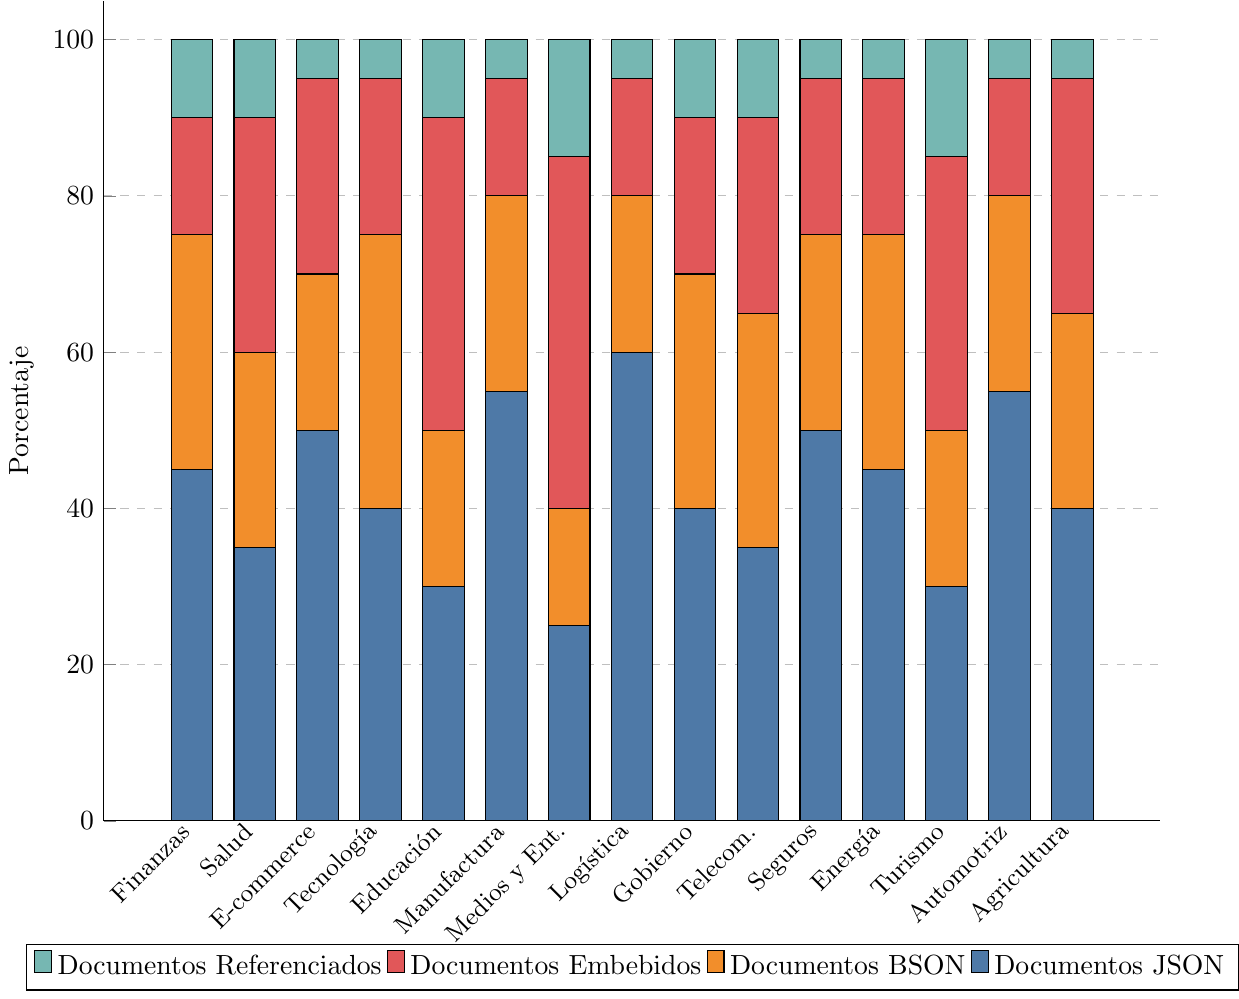What's the industry with the highest number of Documentos JSON? To find the industry with the highest number of Documentos JSON, look at the heights of the blue sections of the bars. The tallest blue section is in the "Logística" category.
Answer: Logística Which industry has the highest total number of documents (sum of all types)? Add the heights of all four sections (JSON, BSON, Embebidos, Referenciados) in each bar. The industry with the highest total is "Logística" (60 + 20 + 15 + 5 = 100).
Answer: Logística In which industry do Documentos Embebidos (red sections) constitute over 30% of the total documents? Calculate 30% of the total documents for each industry and check if the red section exceeds this value. For "Medios y Entretenimiento" (25 + 15 + 45 + 15 = 100; 30% of 100 is 30), Documentos Embebidos constitute 45, which is over 30.
Answer: Medios y Entretenimiento How many Documentos Referenciados (green sections) are there in Gobierno? Count the height of the green section in the "Gobierno" category.
Answer: 10 Compare the total number of documents in Salud and Energía industries. Which has more? Sum all sections for Salud (35 + 25 + 30 + 10 = 100) and for Energía (45 + 30 + 20 + 5 = 100). Both have the same total.
Answer: Both have the same Which industries have fewer Documentos BSON (orange sections) than Documentos JSON (blue sections)? Compare the height of the orange section to the blue section in each industry. They are "E-commerce", "Medios y Entretenimiento", "Logística", "Energía", "Automotriz", and "Agricultura".
Answer: E-commerce, Medios y Entretenimiento, Logística, Energía, Automotriz, Agricultura What is the color representation of Documentos Embebidos in the chart? Identify the color used for Documentos Embebidos in the legend.
Answer: Red Which industry has the least number of Documentos Referenciados? Examine the green sections, the smallest belongs to "E-commerce", "Tecnología", "Manufactura", "Logística", "Telecomunicaciones", "Seguros", "Energía", "Automotriz", and "Agricultura", all having the same minimum value of 5.
Answer: E-commerce, Tecnología, Manufactura, Logística, Telecomunicaciones, Seguros, Energía, Automotriz, Agricultura How many industries have at least 50 Documentos JSON? Observe the heights of the blue sections and count the number of industries where the height is 50 or more: "E-commerce", "Manufactura", "Seguros", and "Automotriz".
Answer: 4 